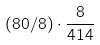<formula> <loc_0><loc_0><loc_500><loc_500>( 8 0 / 8 ) \cdot \frac { 8 } { 4 1 4 }</formula> 